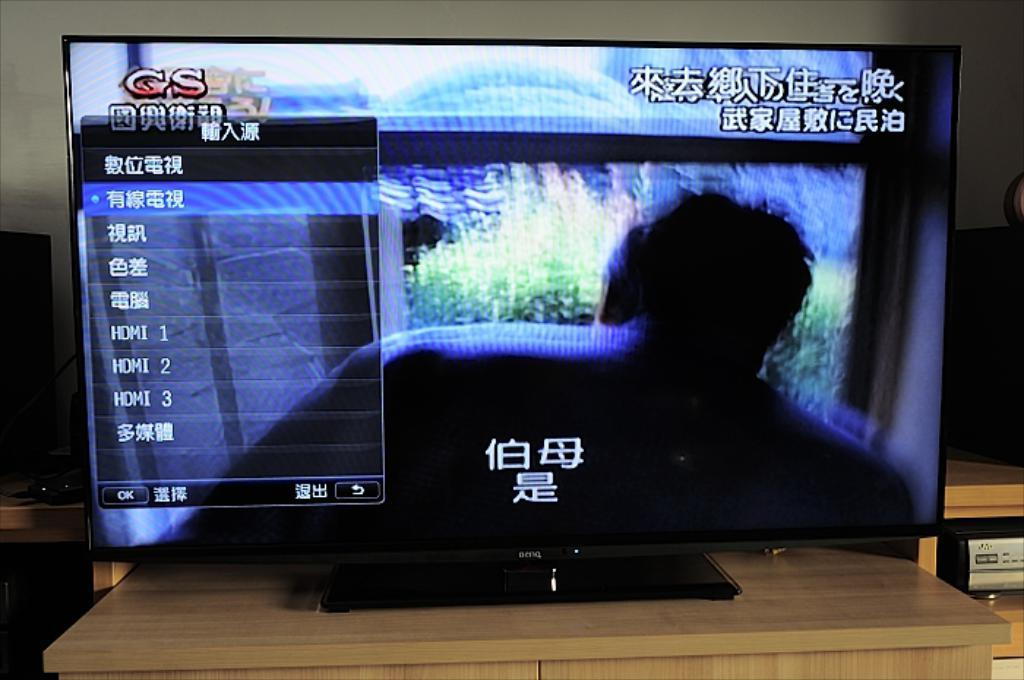<image>
Relay a brief, clear account of the picture shown. A television displaying a menu of options written in chinese with a logo for GS at the top left. 